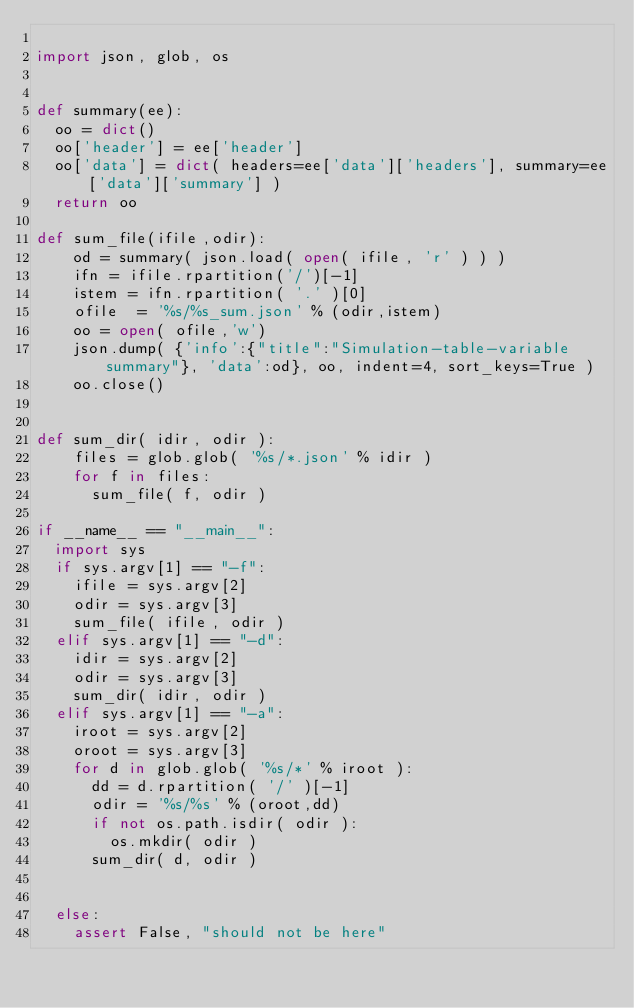<code> <loc_0><loc_0><loc_500><loc_500><_Python_>
import json, glob, os


def summary(ee):
  oo = dict()
  oo['header'] = ee['header']
  oo['data'] = dict( headers=ee['data']['headers'], summary=ee['data']['summary'] )
  return oo

def sum_file(ifile,odir):
    od = summary( json.load( open( ifile, 'r' ) ) )
    ifn = ifile.rpartition('/')[-1]
    istem = ifn.rpartition( '.' )[0]
    ofile  = '%s/%s_sum.json' % (odir,istem)
    oo = open( ofile,'w')
    json.dump( {'info':{"title":"Simulation-table-variable summary"}, 'data':od}, oo, indent=4, sort_keys=True )
    oo.close()


def sum_dir( idir, odir ):
    files = glob.glob( '%s/*.json' % idir )
    for f in files:
      sum_file( f, odir )

if __name__ == "__main__":
  import sys
  if sys.argv[1] == "-f":
    ifile = sys.argv[2]
    odir = sys.argv[3]
    sum_file( ifile, odir )
  elif sys.argv[1] == "-d":
    idir = sys.argv[2]
    odir = sys.argv[3]
    sum_dir( idir, odir )
  elif sys.argv[1] == "-a":
    iroot = sys.argv[2]
    oroot = sys.argv[3]
    for d in glob.glob( '%s/*' % iroot ):
      dd = d.rpartition( '/' )[-1]
      odir = '%s/%s' % (oroot,dd)
      if not os.path.isdir( odir ):
        os.mkdir( odir )
      sum_dir( d, odir )
  
    
  else:
    assert False, "should not be here"
</code> 